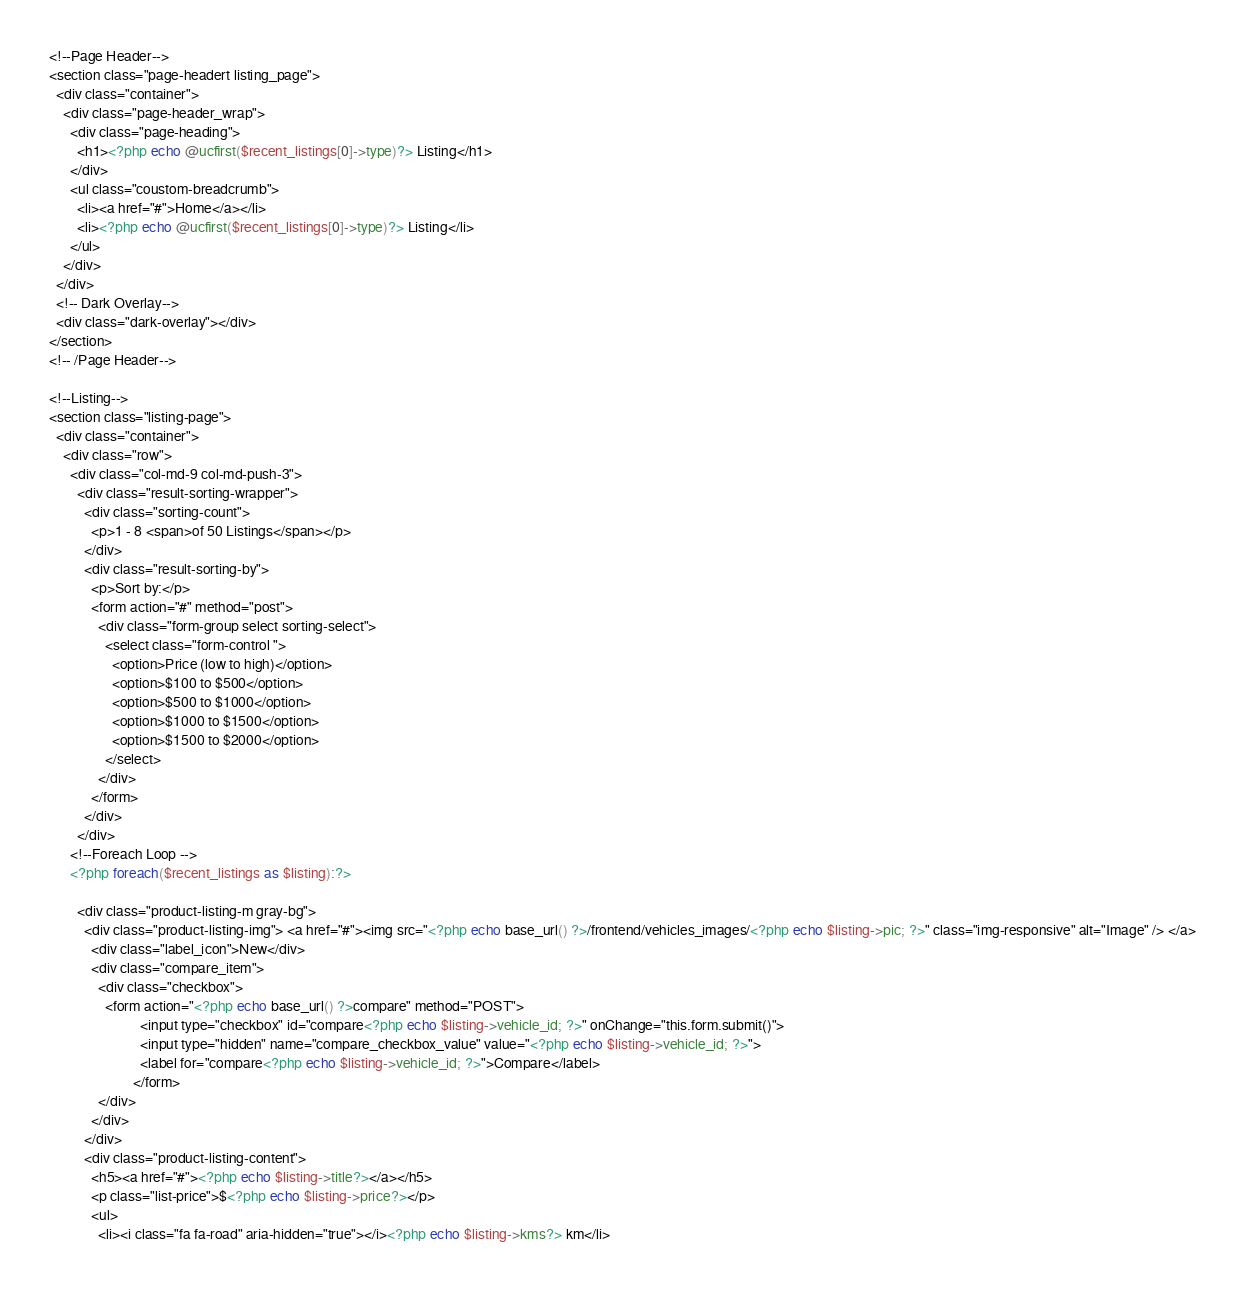Convert code to text. <code><loc_0><loc_0><loc_500><loc_500><_PHP_>
<!--Page Header-->
<section class="page-headert listing_page">
  <div class="container">
    <div class="page-header_wrap">
      <div class="page-heading">
        <h1><?php echo @ucfirst($recent_listings[0]->type)?> Listing</h1>
      </div>
      <ul class="coustom-breadcrumb">
        <li><a href="#">Home</a></li>
        <li><?php echo @ucfirst($recent_listings[0]->type)?> Listing</li>
      </ul>
    </div>
  </div>
  <!-- Dark Overlay-->
  <div class="dark-overlay"></div>
</section>
<!-- /Page Header--> 

<!--Listing-->
<section class="listing-page">
  <div class="container">
    <div class="row">
      <div class="col-md-9 col-md-push-3">
        <div class="result-sorting-wrapper">
          <div class="sorting-count">
            <p>1 - 8 <span>of 50 Listings</span></p>
          </div>
          <div class="result-sorting-by">
            <p>Sort by:</p>
            <form action="#" method="post">
              <div class="form-group select sorting-select">
                <select class="form-control ">
                  <option>Price (low to high)</option>
                  <option>$100 to $500</option>
                  <option>$500 to $1000</option>
                  <option>$1000 to $1500</option>
                  <option>$1500 to $2000</option>
                </select>
              </div>
            </form>
          </div>
        </div>
      <!--Foreach Loop -->
      <?php foreach($recent_listings as $listing):?>

        <div class="product-listing-m gray-bg">
          <div class="product-listing-img"> <a href="#"><img src="<?php echo base_url() ?>/frontend/vehicles_images/<?php echo $listing->pic; ?>" class="img-responsive" alt="Image" /> </a>
            <div class="label_icon">New</div>
            <div class="compare_item">
              <div class="checkbox">
                <form action="<?php echo base_url() ?>compare" method="POST">
                          <input type="checkbox" id="compare<?php echo $listing->vehicle_id; ?>" onChange="this.form.submit()">
                          <input type="hidden" name="compare_checkbox_value" value="<?php echo $listing->vehicle_id; ?>">
                          <label for="compare<?php echo $listing->vehicle_id; ?>">Compare</label>
                        </form>
              </div>
            </div>
          </div>
          <div class="product-listing-content">
            <h5><a href="#"><?php echo $listing->title?></a></h5>
            <p class="list-price">$<?php echo $listing->price?></p>
            <ul>
              <li><i class="fa fa-road" aria-hidden="true"></i><?php echo $listing->kms?> km</li></code> 